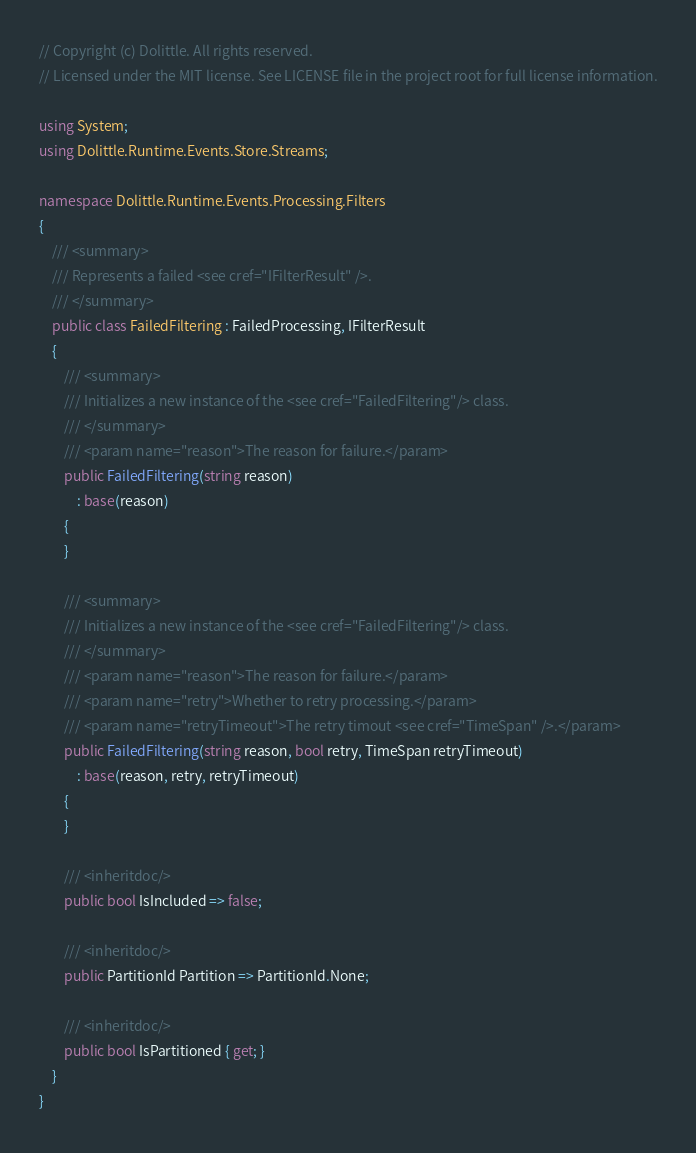<code> <loc_0><loc_0><loc_500><loc_500><_C#_>// Copyright (c) Dolittle. All rights reserved.
// Licensed under the MIT license. See LICENSE file in the project root for full license information.

using System;
using Dolittle.Runtime.Events.Store.Streams;

namespace Dolittle.Runtime.Events.Processing.Filters
{
    /// <summary>
    /// Represents a failed <see cref="IFilterResult" />.
    /// </summary>
    public class FailedFiltering : FailedProcessing, IFilterResult
    {
        /// <summary>
        /// Initializes a new instance of the <see cref="FailedFiltering"/> class.
        /// </summary>
        /// <param name="reason">The reason for failure.</param>
        public FailedFiltering(string reason)
            : base(reason)
        {
        }

        /// <summary>
        /// Initializes a new instance of the <see cref="FailedFiltering"/> class.
        /// </summary>
        /// <param name="reason">The reason for failure.</param>
        /// <param name="retry">Whether to retry processing.</param>
        /// <param name="retryTimeout">The retry timout <see cref="TimeSpan" />.</param>
        public FailedFiltering(string reason, bool retry, TimeSpan retryTimeout)
            : base(reason, retry, retryTimeout)
        {
        }

        /// <inheritdoc/>
        public bool IsIncluded => false;

        /// <inheritdoc/>
        public PartitionId Partition => PartitionId.None;

        /// <inheritdoc/>
        public bool IsPartitioned { get; }
    }
}</code> 